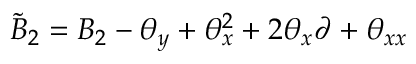<formula> <loc_0><loc_0><loc_500><loc_500>\tilde { B } _ { 2 } = B _ { 2 } - { \theta } _ { y } + { \theta } _ { x } ^ { 2 } + 2 { \theta } _ { x } \partial + { \theta } _ { x x }</formula> 